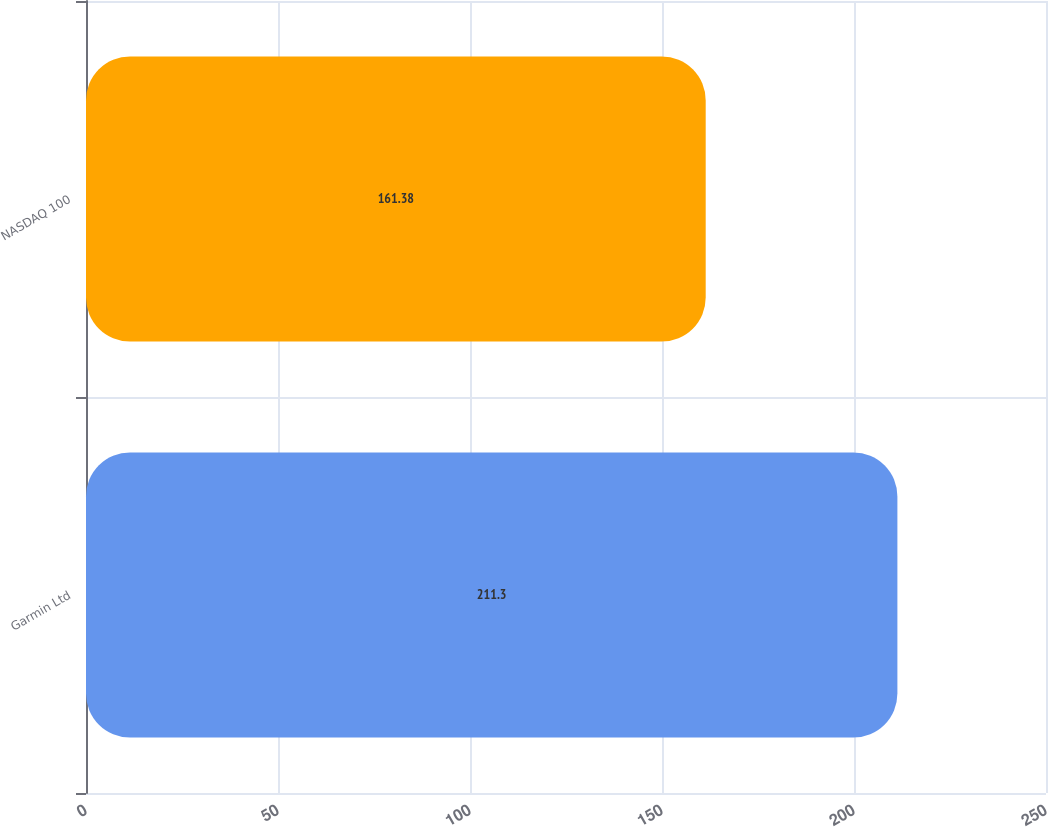<chart> <loc_0><loc_0><loc_500><loc_500><bar_chart><fcel>Garmin Ltd<fcel>NASDAQ 100<nl><fcel>211.3<fcel>161.38<nl></chart> 